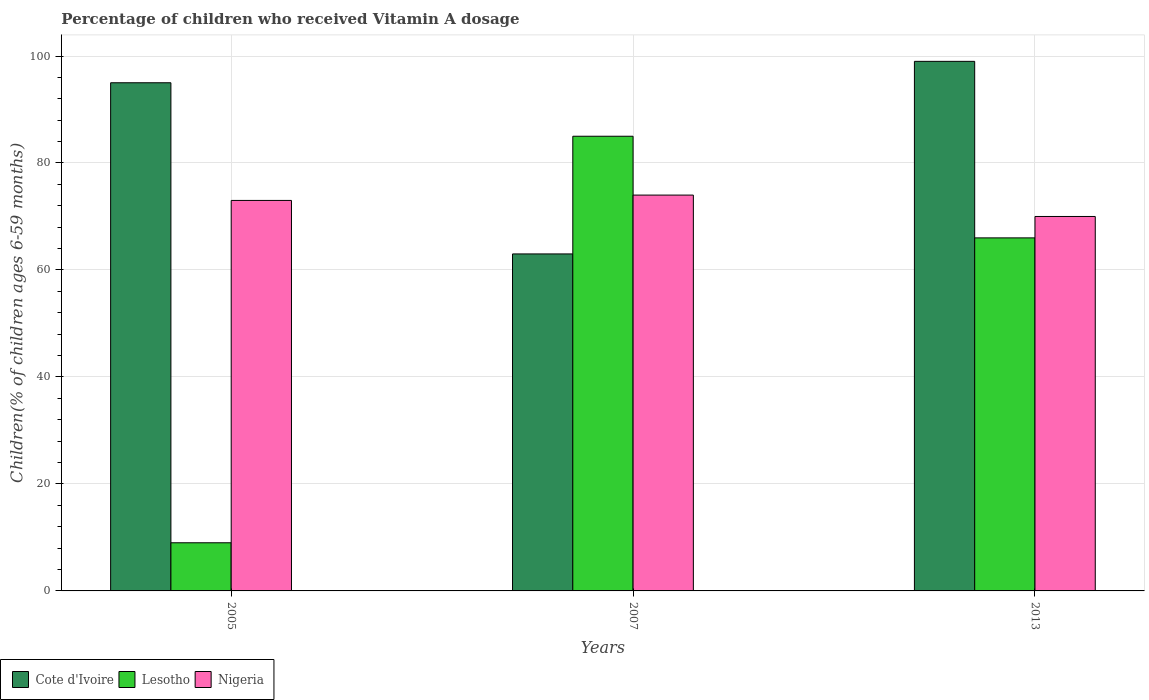How many groups of bars are there?
Offer a terse response. 3. Are the number of bars on each tick of the X-axis equal?
Your response must be concise. Yes. How many bars are there on the 1st tick from the left?
Ensure brevity in your answer.  3. How many bars are there on the 2nd tick from the right?
Your answer should be compact. 3. What is the label of the 2nd group of bars from the left?
Offer a very short reply. 2007. Across all years, what is the maximum percentage of children who received Vitamin A dosage in Lesotho?
Make the answer very short. 85. Across all years, what is the minimum percentage of children who received Vitamin A dosage in Cote d'Ivoire?
Provide a short and direct response. 63. What is the total percentage of children who received Vitamin A dosage in Cote d'Ivoire in the graph?
Your response must be concise. 257. What is the average percentage of children who received Vitamin A dosage in Nigeria per year?
Provide a short and direct response. 72.33. In the year 2007, what is the difference between the percentage of children who received Vitamin A dosage in Lesotho and percentage of children who received Vitamin A dosage in Cote d'Ivoire?
Your answer should be compact. 22. In how many years, is the percentage of children who received Vitamin A dosage in Nigeria greater than 40 %?
Provide a succinct answer. 3. What is the ratio of the percentage of children who received Vitamin A dosage in Nigeria in 2005 to that in 2013?
Your answer should be compact. 1.04. What is the difference between the highest and the second highest percentage of children who received Vitamin A dosage in Cote d'Ivoire?
Ensure brevity in your answer.  4. In how many years, is the percentage of children who received Vitamin A dosage in Lesotho greater than the average percentage of children who received Vitamin A dosage in Lesotho taken over all years?
Make the answer very short. 2. Is the sum of the percentage of children who received Vitamin A dosage in Nigeria in 2005 and 2007 greater than the maximum percentage of children who received Vitamin A dosage in Lesotho across all years?
Offer a terse response. Yes. What does the 1st bar from the left in 2005 represents?
Your answer should be compact. Cote d'Ivoire. What does the 1st bar from the right in 2013 represents?
Ensure brevity in your answer.  Nigeria. Are all the bars in the graph horizontal?
Provide a short and direct response. No. What is the difference between two consecutive major ticks on the Y-axis?
Provide a succinct answer. 20. Does the graph contain any zero values?
Provide a succinct answer. No. Does the graph contain grids?
Your answer should be compact. Yes. Where does the legend appear in the graph?
Offer a terse response. Bottom left. How are the legend labels stacked?
Provide a succinct answer. Horizontal. What is the title of the graph?
Make the answer very short. Percentage of children who received Vitamin A dosage. Does "Timor-Leste" appear as one of the legend labels in the graph?
Your answer should be compact. No. What is the label or title of the Y-axis?
Your response must be concise. Children(% of children ages 6-59 months). What is the Children(% of children ages 6-59 months) in Lesotho in 2005?
Provide a short and direct response. 9. What is the Children(% of children ages 6-59 months) in Lesotho in 2007?
Your answer should be very brief. 85. What is the Children(% of children ages 6-59 months) of Lesotho in 2013?
Provide a succinct answer. 66. What is the Children(% of children ages 6-59 months) of Nigeria in 2013?
Ensure brevity in your answer.  70. Across all years, what is the maximum Children(% of children ages 6-59 months) of Lesotho?
Offer a terse response. 85. Across all years, what is the maximum Children(% of children ages 6-59 months) of Nigeria?
Ensure brevity in your answer.  74. Across all years, what is the minimum Children(% of children ages 6-59 months) in Cote d'Ivoire?
Make the answer very short. 63. Across all years, what is the minimum Children(% of children ages 6-59 months) of Nigeria?
Provide a short and direct response. 70. What is the total Children(% of children ages 6-59 months) of Cote d'Ivoire in the graph?
Keep it short and to the point. 257. What is the total Children(% of children ages 6-59 months) of Lesotho in the graph?
Your response must be concise. 160. What is the total Children(% of children ages 6-59 months) of Nigeria in the graph?
Provide a succinct answer. 217. What is the difference between the Children(% of children ages 6-59 months) of Lesotho in 2005 and that in 2007?
Provide a short and direct response. -76. What is the difference between the Children(% of children ages 6-59 months) of Cote d'Ivoire in 2005 and that in 2013?
Provide a succinct answer. -4. What is the difference between the Children(% of children ages 6-59 months) in Lesotho in 2005 and that in 2013?
Your answer should be compact. -57. What is the difference between the Children(% of children ages 6-59 months) of Cote d'Ivoire in 2007 and that in 2013?
Provide a succinct answer. -36. What is the difference between the Children(% of children ages 6-59 months) in Cote d'Ivoire in 2005 and the Children(% of children ages 6-59 months) in Lesotho in 2007?
Your response must be concise. 10. What is the difference between the Children(% of children ages 6-59 months) in Cote d'Ivoire in 2005 and the Children(% of children ages 6-59 months) in Nigeria in 2007?
Provide a succinct answer. 21. What is the difference between the Children(% of children ages 6-59 months) of Lesotho in 2005 and the Children(% of children ages 6-59 months) of Nigeria in 2007?
Make the answer very short. -65. What is the difference between the Children(% of children ages 6-59 months) of Cote d'Ivoire in 2005 and the Children(% of children ages 6-59 months) of Nigeria in 2013?
Your answer should be compact. 25. What is the difference between the Children(% of children ages 6-59 months) of Lesotho in 2005 and the Children(% of children ages 6-59 months) of Nigeria in 2013?
Offer a terse response. -61. What is the average Children(% of children ages 6-59 months) in Cote d'Ivoire per year?
Keep it short and to the point. 85.67. What is the average Children(% of children ages 6-59 months) of Lesotho per year?
Your answer should be very brief. 53.33. What is the average Children(% of children ages 6-59 months) of Nigeria per year?
Your response must be concise. 72.33. In the year 2005, what is the difference between the Children(% of children ages 6-59 months) of Cote d'Ivoire and Children(% of children ages 6-59 months) of Lesotho?
Provide a succinct answer. 86. In the year 2005, what is the difference between the Children(% of children ages 6-59 months) in Cote d'Ivoire and Children(% of children ages 6-59 months) in Nigeria?
Keep it short and to the point. 22. In the year 2005, what is the difference between the Children(% of children ages 6-59 months) of Lesotho and Children(% of children ages 6-59 months) of Nigeria?
Make the answer very short. -64. What is the ratio of the Children(% of children ages 6-59 months) in Cote d'Ivoire in 2005 to that in 2007?
Make the answer very short. 1.51. What is the ratio of the Children(% of children ages 6-59 months) of Lesotho in 2005 to that in 2007?
Provide a succinct answer. 0.11. What is the ratio of the Children(% of children ages 6-59 months) of Nigeria in 2005 to that in 2007?
Your response must be concise. 0.99. What is the ratio of the Children(% of children ages 6-59 months) in Cote d'Ivoire in 2005 to that in 2013?
Your response must be concise. 0.96. What is the ratio of the Children(% of children ages 6-59 months) of Lesotho in 2005 to that in 2013?
Give a very brief answer. 0.14. What is the ratio of the Children(% of children ages 6-59 months) in Nigeria in 2005 to that in 2013?
Ensure brevity in your answer.  1.04. What is the ratio of the Children(% of children ages 6-59 months) in Cote d'Ivoire in 2007 to that in 2013?
Provide a short and direct response. 0.64. What is the ratio of the Children(% of children ages 6-59 months) of Lesotho in 2007 to that in 2013?
Your response must be concise. 1.29. What is the ratio of the Children(% of children ages 6-59 months) of Nigeria in 2007 to that in 2013?
Give a very brief answer. 1.06. What is the difference between the highest and the second highest Children(% of children ages 6-59 months) in Lesotho?
Keep it short and to the point. 19. What is the difference between the highest and the second highest Children(% of children ages 6-59 months) of Nigeria?
Make the answer very short. 1. What is the difference between the highest and the lowest Children(% of children ages 6-59 months) of Cote d'Ivoire?
Give a very brief answer. 36. What is the difference between the highest and the lowest Children(% of children ages 6-59 months) in Lesotho?
Offer a very short reply. 76. 